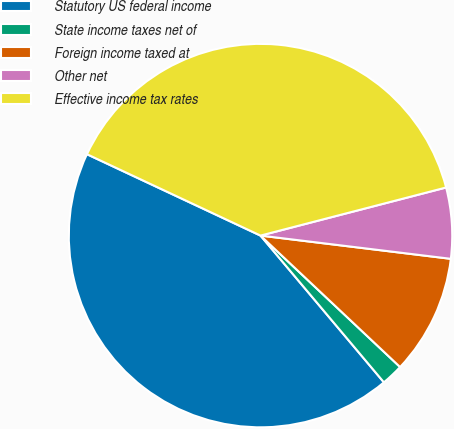<chart> <loc_0><loc_0><loc_500><loc_500><pie_chart><fcel>Statutory US federal income<fcel>State income taxes net of<fcel>Foreign income taxed at<fcel>Other net<fcel>Effective income tax rates<nl><fcel>43.11%<fcel>1.85%<fcel>10.09%<fcel>5.97%<fcel>38.99%<nl></chart> 